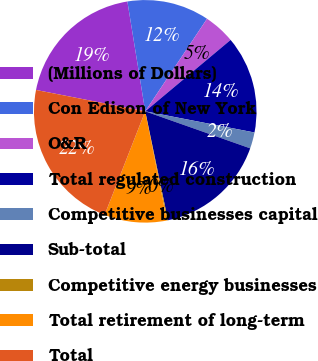<chart> <loc_0><loc_0><loc_500><loc_500><pie_chart><fcel>(Millions of Dollars)<fcel>Con Edison of New York<fcel>O&R<fcel>Total regulated construction<fcel>Competitive businesses capital<fcel>Sub-total<fcel>Competitive energy businesses<fcel>Total retirement of long-term<fcel>Total<nl><fcel>19.36%<fcel>11.93%<fcel>4.55%<fcel>14.13%<fcel>2.35%<fcel>16.33%<fcel>0.15%<fcel>9.07%<fcel>22.13%<nl></chart> 